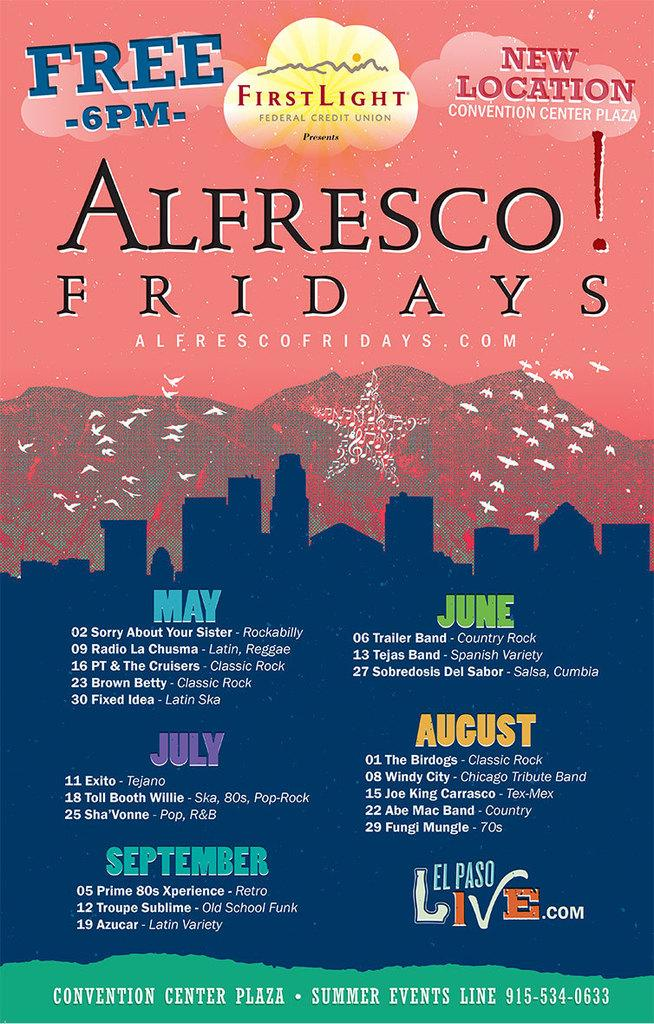<image>
Write a terse but informative summary of the picture. an orange and blue poster about Afresco Fridays 